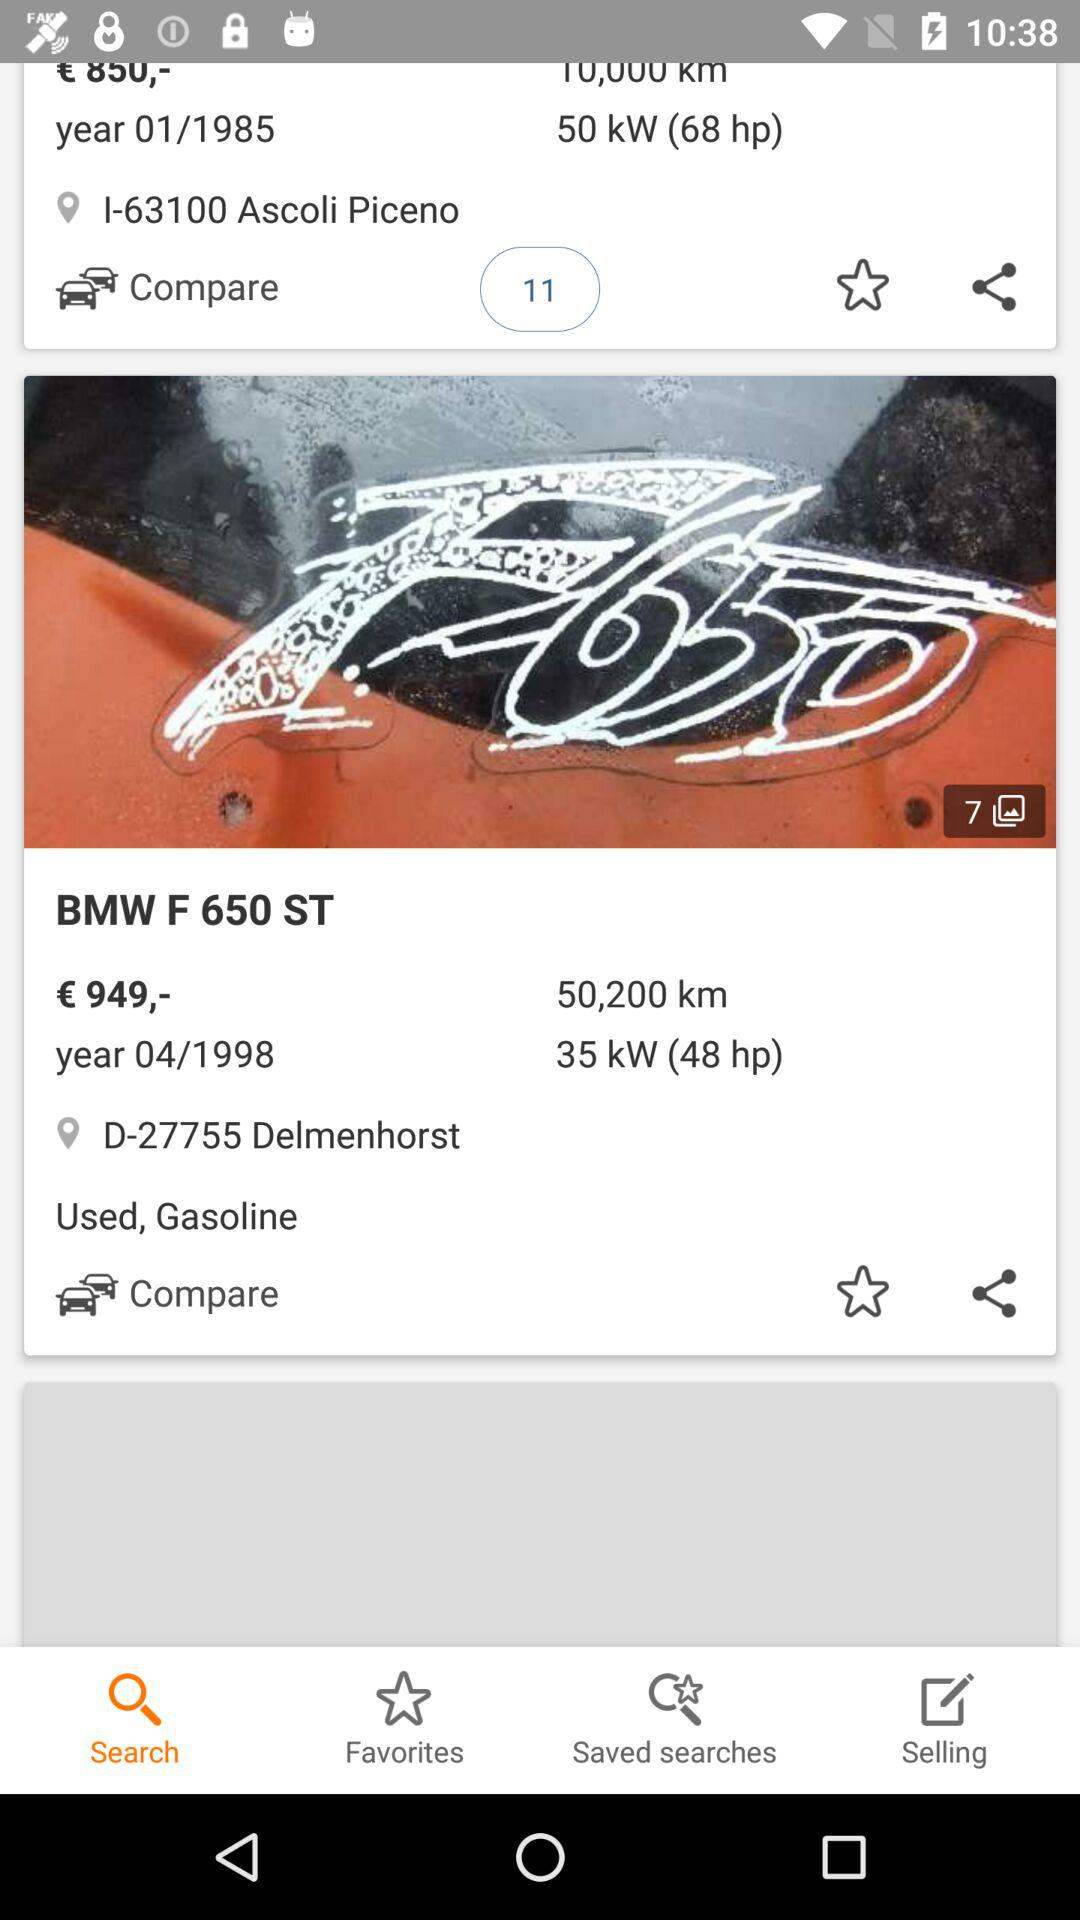Which tab has been selected? The selected tab is "Search". 